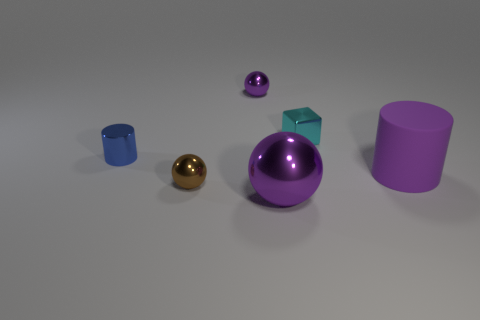Add 3 balls. How many objects exist? 9 Subtract all small metallic spheres. How many spheres are left? 1 Subtract all cylinders. How many objects are left? 4 Subtract all purple spheres. Subtract all brown blocks. How many spheres are left? 1 Subtract all red cubes. How many purple cylinders are left? 1 Subtract all cyan objects. Subtract all tiny cyan metal cubes. How many objects are left? 4 Add 1 brown metal spheres. How many brown metal spheres are left? 2 Add 6 small red balls. How many small red balls exist? 6 Subtract all purple balls. How many balls are left? 1 Subtract 0 green balls. How many objects are left? 6 